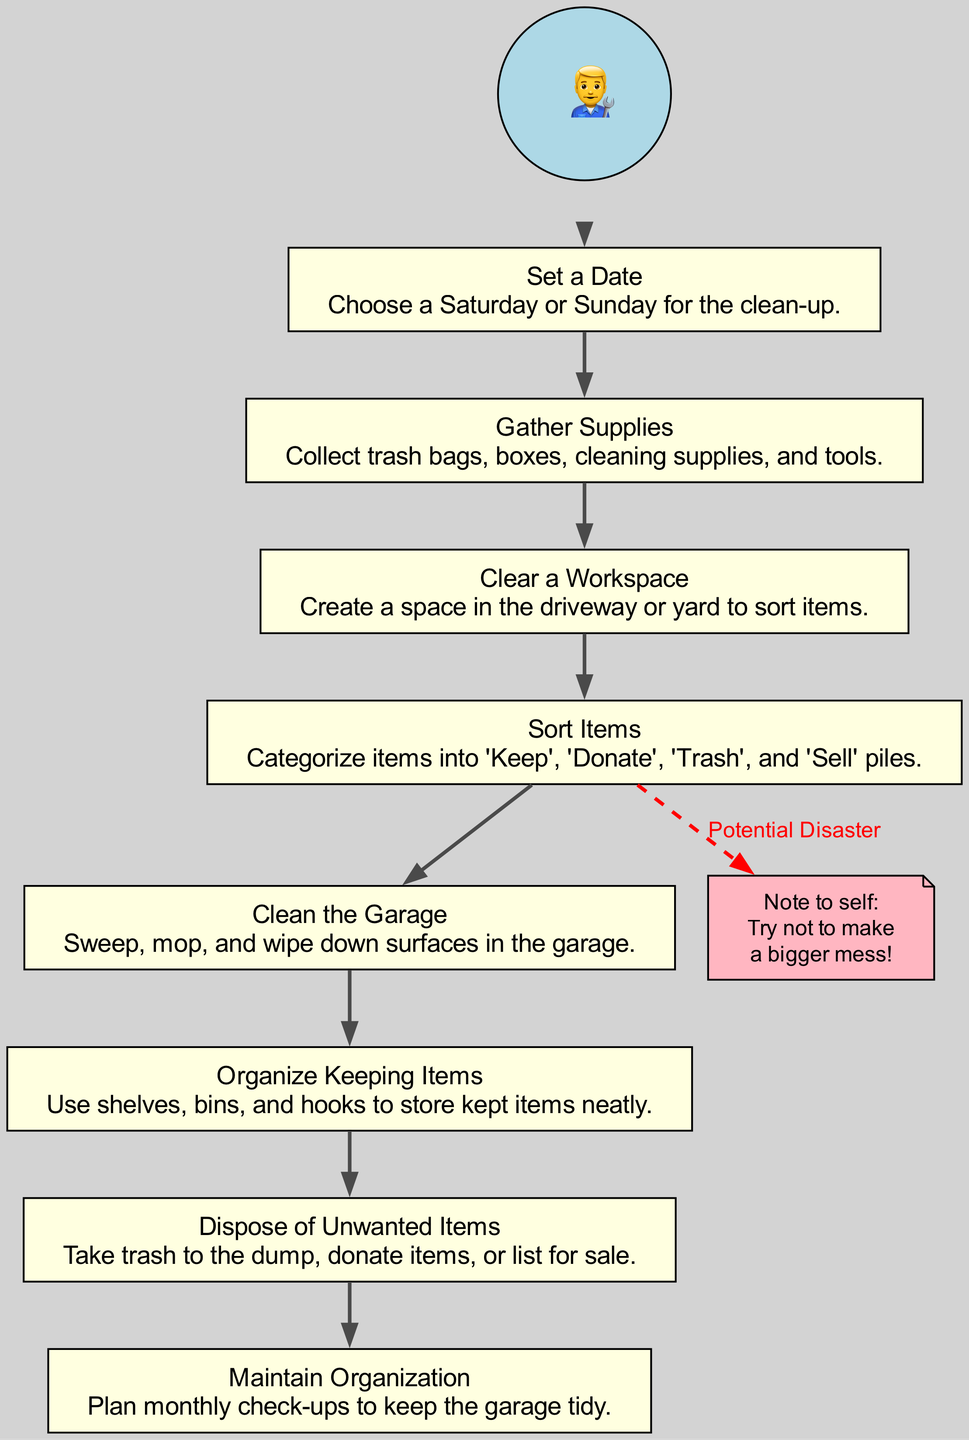What is the first step in the garage clean-up? The first step is "Set a Date," which is indicated as the starting node in the flow chart.
Answer: Set a Date How many steps are there in total? The diagram lists 8 steps from "Set a Date" to "Maintain Organization."
Answer: 8 What item is recommended to gather first? The initial action in the flow is to "Gather Supplies," directly following the date-setting.
Answer: Gather Supplies What follows the "Sort Items" step? After "Sort Items," the next action is "Clean the Garage," indicating the sequence of operations.
Answer: Clean the Garage What is the purpose of the messy note? The messy note serves as a reminder to avoid making a bigger mess during the "Sort Items" stage, highlighting a potential issue.
Answer: Potential Disaster How do you maintain organization after the clean-up? The last step outlined is "Maintain Organization," illustrating the importance of ongoing upkeep after the initial clean-up.
Answer: Maintain Organization What shape is used for the messy note? The messy note is represented as a "note" shape in the diagram, visually distinct from the other rectangular steps.
Answer: Note Which step requires the most items to dispose of? The step "Dispose of Unwanted Items" deals with handling items categorized as 'Trash,' 'Donate,' and 'Sell,’ indicating a need to manage multiple types of unwanted items.
Answer: Dispose of Unwanted Items 